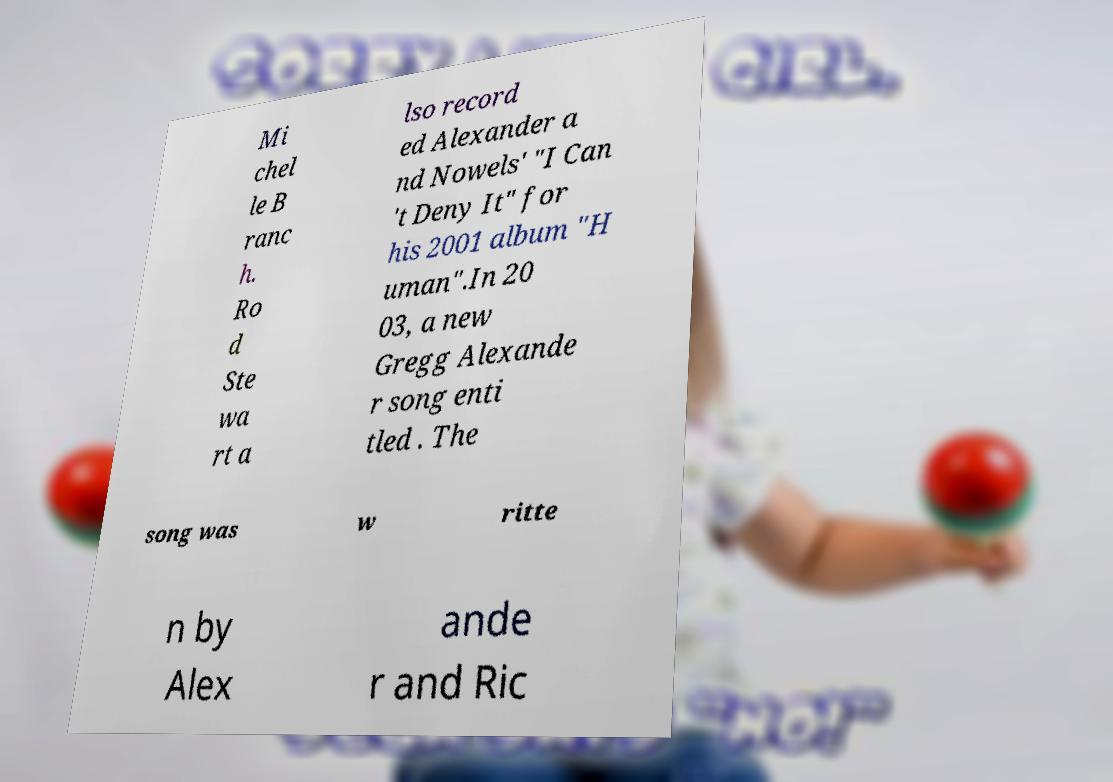I need the written content from this picture converted into text. Can you do that? Mi chel le B ranc h. Ro d Ste wa rt a lso record ed Alexander a nd Nowels' "I Can 't Deny It" for his 2001 album "H uman".In 20 03, a new Gregg Alexande r song enti tled . The song was w ritte n by Alex ande r and Ric 